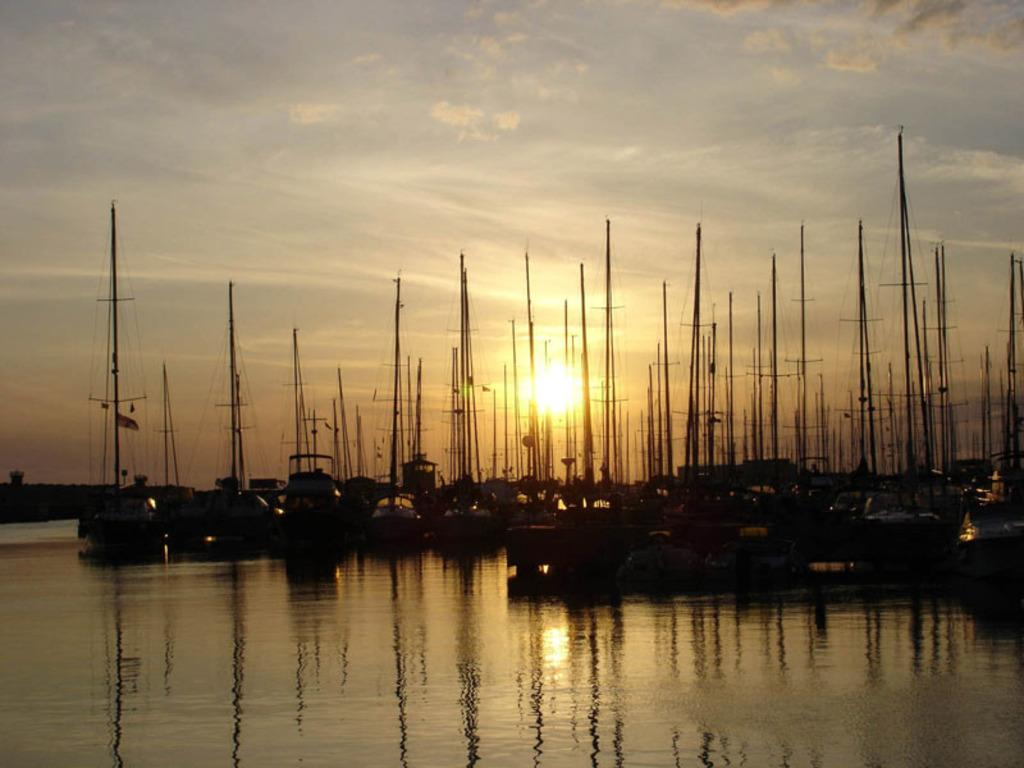What type of vehicles are in the image? There are ships in the image. Where are the ships located? The ships are on a river. What can be seen in the sky in the background of the image? There is a sunrise visible in the sky in the background of the image. How many chess pieces are on the ships in the image? There are no chess pieces present in the image; it features ships on a river with a sunrise in the background. 